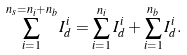Convert formula to latex. <formula><loc_0><loc_0><loc_500><loc_500>\sum _ { i = 1 } ^ { n _ { s } = n _ { i } + n _ { b } } I _ { d } ^ { i } = \sum _ { i = 1 } ^ { n _ { i } } I _ { d } ^ { i } + \sum _ { i = 1 } ^ { n _ { b } } I _ { d } ^ { i } .</formula> 